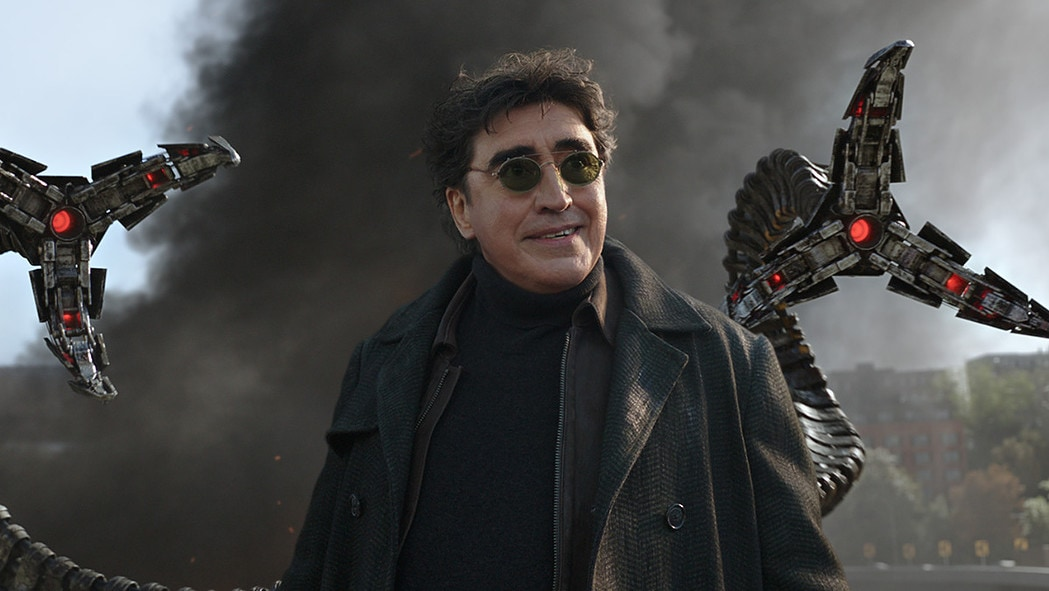What's happening in the scene? In this image, we see an actor portraying the character Doctor Octopus from the Spider-Man series. He stands confidently at the center of the frame, partially hidden behind dark sunglasses. His black coat enhances his commanding presence. On both sides of him, there are the iconic mechanical tentacles of Doctor Octopus. The background, filled with smoke and urban structures, suggests a dramatic and intense setting, echoing the dangerous and thrilling nature of the character. 